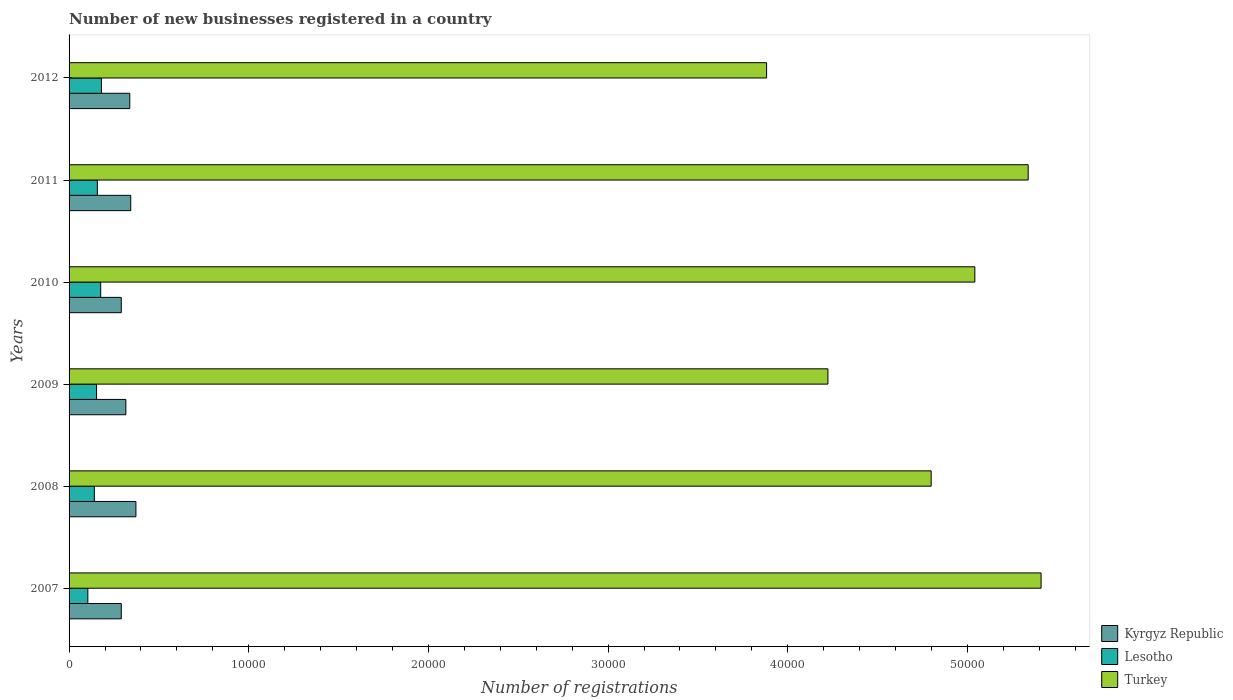How many different coloured bars are there?
Offer a terse response. 3. How many groups of bars are there?
Give a very brief answer. 6. How many bars are there on the 5th tick from the top?
Give a very brief answer. 3. What is the label of the 5th group of bars from the top?
Provide a short and direct response. 2008. In how many cases, is the number of bars for a given year not equal to the number of legend labels?
Offer a very short reply. 0. What is the number of new businesses registered in Turkey in 2012?
Give a very brief answer. 3.88e+04. Across all years, what is the maximum number of new businesses registered in Turkey?
Provide a succinct answer. 5.41e+04. Across all years, what is the minimum number of new businesses registered in Turkey?
Offer a terse response. 3.88e+04. In which year was the number of new businesses registered in Lesotho minimum?
Provide a succinct answer. 2007. What is the total number of new businesses registered in Lesotho in the graph?
Provide a short and direct response. 9118. What is the difference between the number of new businesses registered in Kyrgyz Republic in 2008 and that in 2009?
Offer a very short reply. 560. What is the difference between the number of new businesses registered in Lesotho in 2010 and the number of new businesses registered in Kyrgyz Republic in 2007?
Your answer should be very brief. -1145. What is the average number of new businesses registered in Lesotho per year?
Make the answer very short. 1519.67. In the year 2010, what is the difference between the number of new businesses registered in Lesotho and number of new businesses registered in Turkey?
Offer a very short reply. -4.87e+04. In how many years, is the number of new businesses registered in Turkey greater than 48000 ?
Provide a short and direct response. 3. What is the ratio of the number of new businesses registered in Turkey in 2010 to that in 2012?
Offer a very short reply. 1.3. What is the difference between the highest and the second highest number of new businesses registered in Lesotho?
Your response must be concise. 40. What is the difference between the highest and the lowest number of new businesses registered in Lesotho?
Keep it short and to the point. 756. In how many years, is the number of new businesses registered in Turkey greater than the average number of new businesses registered in Turkey taken over all years?
Keep it short and to the point. 4. Is the sum of the number of new businesses registered in Turkey in 2007 and 2010 greater than the maximum number of new businesses registered in Lesotho across all years?
Make the answer very short. Yes. What does the 1st bar from the top in 2010 represents?
Give a very brief answer. Turkey. What does the 2nd bar from the bottom in 2010 represents?
Give a very brief answer. Lesotho. Is it the case that in every year, the sum of the number of new businesses registered in Lesotho and number of new businesses registered in Turkey is greater than the number of new businesses registered in Kyrgyz Republic?
Provide a succinct answer. Yes. How many bars are there?
Your response must be concise. 18. What is the difference between two consecutive major ticks on the X-axis?
Make the answer very short. 10000. What is the title of the graph?
Offer a terse response. Number of new businesses registered in a country. What is the label or title of the X-axis?
Your answer should be compact. Number of registrations. What is the Number of registrations of Kyrgyz Republic in 2007?
Give a very brief answer. 2906. What is the Number of registrations in Lesotho in 2007?
Offer a terse response. 1045. What is the Number of registrations in Turkey in 2007?
Make the answer very short. 5.41e+04. What is the Number of registrations of Kyrgyz Republic in 2008?
Ensure brevity in your answer.  3721. What is the Number of registrations of Lesotho in 2008?
Ensure brevity in your answer.  1407. What is the Number of registrations of Turkey in 2008?
Keep it short and to the point. 4.80e+04. What is the Number of registrations of Kyrgyz Republic in 2009?
Your answer should be compact. 3161. What is the Number of registrations in Lesotho in 2009?
Give a very brief answer. 1531. What is the Number of registrations of Turkey in 2009?
Your response must be concise. 4.22e+04. What is the Number of registrations in Kyrgyz Republic in 2010?
Offer a terse response. 2905. What is the Number of registrations of Lesotho in 2010?
Your answer should be compact. 1761. What is the Number of registrations in Turkey in 2010?
Ensure brevity in your answer.  5.04e+04. What is the Number of registrations in Kyrgyz Republic in 2011?
Give a very brief answer. 3433. What is the Number of registrations of Lesotho in 2011?
Keep it short and to the point. 1573. What is the Number of registrations of Turkey in 2011?
Provide a short and direct response. 5.34e+04. What is the Number of registrations in Kyrgyz Republic in 2012?
Provide a short and direct response. 3379. What is the Number of registrations in Lesotho in 2012?
Ensure brevity in your answer.  1801. What is the Number of registrations in Turkey in 2012?
Give a very brief answer. 3.88e+04. Across all years, what is the maximum Number of registrations in Kyrgyz Republic?
Make the answer very short. 3721. Across all years, what is the maximum Number of registrations in Lesotho?
Provide a succinct answer. 1801. Across all years, what is the maximum Number of registrations of Turkey?
Offer a terse response. 5.41e+04. Across all years, what is the minimum Number of registrations in Kyrgyz Republic?
Give a very brief answer. 2905. Across all years, what is the minimum Number of registrations of Lesotho?
Make the answer very short. 1045. Across all years, what is the minimum Number of registrations in Turkey?
Offer a terse response. 3.88e+04. What is the total Number of registrations of Kyrgyz Republic in the graph?
Your response must be concise. 1.95e+04. What is the total Number of registrations in Lesotho in the graph?
Offer a terse response. 9118. What is the total Number of registrations of Turkey in the graph?
Ensure brevity in your answer.  2.87e+05. What is the difference between the Number of registrations of Kyrgyz Republic in 2007 and that in 2008?
Make the answer very short. -815. What is the difference between the Number of registrations of Lesotho in 2007 and that in 2008?
Offer a very short reply. -362. What is the difference between the Number of registrations in Turkey in 2007 and that in 2008?
Offer a very short reply. 6118. What is the difference between the Number of registrations in Kyrgyz Republic in 2007 and that in 2009?
Ensure brevity in your answer.  -255. What is the difference between the Number of registrations in Lesotho in 2007 and that in 2009?
Give a very brief answer. -486. What is the difference between the Number of registrations of Turkey in 2007 and that in 2009?
Your answer should be compact. 1.19e+04. What is the difference between the Number of registrations of Kyrgyz Republic in 2007 and that in 2010?
Give a very brief answer. 1. What is the difference between the Number of registrations of Lesotho in 2007 and that in 2010?
Your answer should be compact. -716. What is the difference between the Number of registrations of Turkey in 2007 and that in 2010?
Make the answer very short. 3687. What is the difference between the Number of registrations of Kyrgyz Republic in 2007 and that in 2011?
Provide a short and direct response. -527. What is the difference between the Number of registrations in Lesotho in 2007 and that in 2011?
Provide a short and direct response. -528. What is the difference between the Number of registrations of Turkey in 2007 and that in 2011?
Make the answer very short. 718. What is the difference between the Number of registrations in Kyrgyz Republic in 2007 and that in 2012?
Give a very brief answer. -473. What is the difference between the Number of registrations in Lesotho in 2007 and that in 2012?
Offer a terse response. -756. What is the difference between the Number of registrations of Turkey in 2007 and that in 2012?
Provide a short and direct response. 1.53e+04. What is the difference between the Number of registrations in Kyrgyz Republic in 2008 and that in 2009?
Ensure brevity in your answer.  560. What is the difference between the Number of registrations in Lesotho in 2008 and that in 2009?
Make the answer very short. -124. What is the difference between the Number of registrations of Turkey in 2008 and that in 2009?
Provide a succinct answer. 5746. What is the difference between the Number of registrations of Kyrgyz Republic in 2008 and that in 2010?
Provide a succinct answer. 816. What is the difference between the Number of registrations in Lesotho in 2008 and that in 2010?
Offer a very short reply. -354. What is the difference between the Number of registrations of Turkey in 2008 and that in 2010?
Your response must be concise. -2431. What is the difference between the Number of registrations in Kyrgyz Republic in 2008 and that in 2011?
Offer a very short reply. 288. What is the difference between the Number of registrations of Lesotho in 2008 and that in 2011?
Provide a short and direct response. -166. What is the difference between the Number of registrations in Turkey in 2008 and that in 2011?
Your answer should be very brief. -5400. What is the difference between the Number of registrations of Kyrgyz Republic in 2008 and that in 2012?
Provide a short and direct response. 342. What is the difference between the Number of registrations in Lesotho in 2008 and that in 2012?
Offer a terse response. -394. What is the difference between the Number of registrations in Turkey in 2008 and that in 2012?
Keep it short and to the point. 9160. What is the difference between the Number of registrations of Kyrgyz Republic in 2009 and that in 2010?
Ensure brevity in your answer.  256. What is the difference between the Number of registrations in Lesotho in 2009 and that in 2010?
Offer a very short reply. -230. What is the difference between the Number of registrations of Turkey in 2009 and that in 2010?
Make the answer very short. -8177. What is the difference between the Number of registrations in Kyrgyz Republic in 2009 and that in 2011?
Offer a very short reply. -272. What is the difference between the Number of registrations in Lesotho in 2009 and that in 2011?
Give a very brief answer. -42. What is the difference between the Number of registrations of Turkey in 2009 and that in 2011?
Ensure brevity in your answer.  -1.11e+04. What is the difference between the Number of registrations in Kyrgyz Republic in 2009 and that in 2012?
Provide a succinct answer. -218. What is the difference between the Number of registrations of Lesotho in 2009 and that in 2012?
Provide a short and direct response. -270. What is the difference between the Number of registrations of Turkey in 2009 and that in 2012?
Make the answer very short. 3414. What is the difference between the Number of registrations in Kyrgyz Republic in 2010 and that in 2011?
Ensure brevity in your answer.  -528. What is the difference between the Number of registrations of Lesotho in 2010 and that in 2011?
Make the answer very short. 188. What is the difference between the Number of registrations of Turkey in 2010 and that in 2011?
Provide a succinct answer. -2969. What is the difference between the Number of registrations in Kyrgyz Republic in 2010 and that in 2012?
Offer a terse response. -474. What is the difference between the Number of registrations in Turkey in 2010 and that in 2012?
Your answer should be very brief. 1.16e+04. What is the difference between the Number of registrations in Lesotho in 2011 and that in 2012?
Offer a terse response. -228. What is the difference between the Number of registrations in Turkey in 2011 and that in 2012?
Offer a terse response. 1.46e+04. What is the difference between the Number of registrations in Kyrgyz Republic in 2007 and the Number of registrations in Lesotho in 2008?
Ensure brevity in your answer.  1499. What is the difference between the Number of registrations of Kyrgyz Republic in 2007 and the Number of registrations of Turkey in 2008?
Offer a terse response. -4.51e+04. What is the difference between the Number of registrations in Lesotho in 2007 and the Number of registrations in Turkey in 2008?
Your response must be concise. -4.69e+04. What is the difference between the Number of registrations of Kyrgyz Republic in 2007 and the Number of registrations of Lesotho in 2009?
Make the answer very short. 1375. What is the difference between the Number of registrations of Kyrgyz Republic in 2007 and the Number of registrations of Turkey in 2009?
Keep it short and to the point. -3.93e+04. What is the difference between the Number of registrations in Lesotho in 2007 and the Number of registrations in Turkey in 2009?
Ensure brevity in your answer.  -4.12e+04. What is the difference between the Number of registrations in Kyrgyz Republic in 2007 and the Number of registrations in Lesotho in 2010?
Offer a terse response. 1145. What is the difference between the Number of registrations in Kyrgyz Republic in 2007 and the Number of registrations in Turkey in 2010?
Keep it short and to the point. -4.75e+04. What is the difference between the Number of registrations in Lesotho in 2007 and the Number of registrations in Turkey in 2010?
Give a very brief answer. -4.94e+04. What is the difference between the Number of registrations of Kyrgyz Republic in 2007 and the Number of registrations of Lesotho in 2011?
Your answer should be very brief. 1333. What is the difference between the Number of registrations in Kyrgyz Republic in 2007 and the Number of registrations in Turkey in 2011?
Give a very brief answer. -5.05e+04. What is the difference between the Number of registrations of Lesotho in 2007 and the Number of registrations of Turkey in 2011?
Keep it short and to the point. -5.23e+04. What is the difference between the Number of registrations in Kyrgyz Republic in 2007 and the Number of registrations in Lesotho in 2012?
Provide a succinct answer. 1105. What is the difference between the Number of registrations in Kyrgyz Republic in 2007 and the Number of registrations in Turkey in 2012?
Give a very brief answer. -3.59e+04. What is the difference between the Number of registrations of Lesotho in 2007 and the Number of registrations of Turkey in 2012?
Your response must be concise. -3.78e+04. What is the difference between the Number of registrations of Kyrgyz Republic in 2008 and the Number of registrations of Lesotho in 2009?
Ensure brevity in your answer.  2190. What is the difference between the Number of registrations of Kyrgyz Republic in 2008 and the Number of registrations of Turkey in 2009?
Provide a short and direct response. -3.85e+04. What is the difference between the Number of registrations in Lesotho in 2008 and the Number of registrations in Turkey in 2009?
Provide a short and direct response. -4.08e+04. What is the difference between the Number of registrations in Kyrgyz Republic in 2008 and the Number of registrations in Lesotho in 2010?
Provide a succinct answer. 1960. What is the difference between the Number of registrations of Kyrgyz Republic in 2008 and the Number of registrations of Turkey in 2010?
Provide a succinct answer. -4.67e+04. What is the difference between the Number of registrations of Lesotho in 2008 and the Number of registrations of Turkey in 2010?
Provide a succinct answer. -4.90e+04. What is the difference between the Number of registrations of Kyrgyz Republic in 2008 and the Number of registrations of Lesotho in 2011?
Your answer should be very brief. 2148. What is the difference between the Number of registrations in Kyrgyz Republic in 2008 and the Number of registrations in Turkey in 2011?
Keep it short and to the point. -4.97e+04. What is the difference between the Number of registrations in Lesotho in 2008 and the Number of registrations in Turkey in 2011?
Your answer should be compact. -5.20e+04. What is the difference between the Number of registrations in Kyrgyz Republic in 2008 and the Number of registrations in Lesotho in 2012?
Offer a terse response. 1920. What is the difference between the Number of registrations of Kyrgyz Republic in 2008 and the Number of registrations of Turkey in 2012?
Make the answer very short. -3.51e+04. What is the difference between the Number of registrations of Lesotho in 2008 and the Number of registrations of Turkey in 2012?
Your response must be concise. -3.74e+04. What is the difference between the Number of registrations of Kyrgyz Republic in 2009 and the Number of registrations of Lesotho in 2010?
Offer a terse response. 1400. What is the difference between the Number of registrations in Kyrgyz Republic in 2009 and the Number of registrations in Turkey in 2010?
Provide a short and direct response. -4.73e+04. What is the difference between the Number of registrations of Lesotho in 2009 and the Number of registrations of Turkey in 2010?
Provide a short and direct response. -4.89e+04. What is the difference between the Number of registrations in Kyrgyz Republic in 2009 and the Number of registrations in Lesotho in 2011?
Ensure brevity in your answer.  1588. What is the difference between the Number of registrations of Kyrgyz Republic in 2009 and the Number of registrations of Turkey in 2011?
Your response must be concise. -5.02e+04. What is the difference between the Number of registrations of Lesotho in 2009 and the Number of registrations of Turkey in 2011?
Keep it short and to the point. -5.19e+04. What is the difference between the Number of registrations in Kyrgyz Republic in 2009 and the Number of registrations in Lesotho in 2012?
Keep it short and to the point. 1360. What is the difference between the Number of registrations in Kyrgyz Republic in 2009 and the Number of registrations in Turkey in 2012?
Make the answer very short. -3.57e+04. What is the difference between the Number of registrations in Lesotho in 2009 and the Number of registrations in Turkey in 2012?
Make the answer very short. -3.73e+04. What is the difference between the Number of registrations in Kyrgyz Republic in 2010 and the Number of registrations in Lesotho in 2011?
Make the answer very short. 1332. What is the difference between the Number of registrations of Kyrgyz Republic in 2010 and the Number of registrations of Turkey in 2011?
Give a very brief answer. -5.05e+04. What is the difference between the Number of registrations in Lesotho in 2010 and the Number of registrations in Turkey in 2011?
Your response must be concise. -5.16e+04. What is the difference between the Number of registrations of Kyrgyz Republic in 2010 and the Number of registrations of Lesotho in 2012?
Give a very brief answer. 1104. What is the difference between the Number of registrations in Kyrgyz Republic in 2010 and the Number of registrations in Turkey in 2012?
Provide a succinct answer. -3.59e+04. What is the difference between the Number of registrations of Lesotho in 2010 and the Number of registrations of Turkey in 2012?
Keep it short and to the point. -3.71e+04. What is the difference between the Number of registrations of Kyrgyz Republic in 2011 and the Number of registrations of Lesotho in 2012?
Make the answer very short. 1632. What is the difference between the Number of registrations of Kyrgyz Republic in 2011 and the Number of registrations of Turkey in 2012?
Keep it short and to the point. -3.54e+04. What is the difference between the Number of registrations of Lesotho in 2011 and the Number of registrations of Turkey in 2012?
Make the answer very short. -3.72e+04. What is the average Number of registrations of Kyrgyz Republic per year?
Your answer should be compact. 3250.83. What is the average Number of registrations in Lesotho per year?
Ensure brevity in your answer.  1519.67. What is the average Number of registrations in Turkey per year?
Keep it short and to the point. 4.78e+04. In the year 2007, what is the difference between the Number of registrations in Kyrgyz Republic and Number of registrations in Lesotho?
Provide a short and direct response. 1861. In the year 2007, what is the difference between the Number of registrations of Kyrgyz Republic and Number of registrations of Turkey?
Give a very brief answer. -5.12e+04. In the year 2007, what is the difference between the Number of registrations of Lesotho and Number of registrations of Turkey?
Your response must be concise. -5.31e+04. In the year 2008, what is the difference between the Number of registrations of Kyrgyz Republic and Number of registrations of Lesotho?
Your answer should be compact. 2314. In the year 2008, what is the difference between the Number of registrations of Kyrgyz Republic and Number of registrations of Turkey?
Make the answer very short. -4.43e+04. In the year 2008, what is the difference between the Number of registrations of Lesotho and Number of registrations of Turkey?
Offer a very short reply. -4.66e+04. In the year 2009, what is the difference between the Number of registrations in Kyrgyz Republic and Number of registrations in Lesotho?
Your response must be concise. 1630. In the year 2009, what is the difference between the Number of registrations of Kyrgyz Republic and Number of registrations of Turkey?
Give a very brief answer. -3.91e+04. In the year 2009, what is the difference between the Number of registrations in Lesotho and Number of registrations in Turkey?
Ensure brevity in your answer.  -4.07e+04. In the year 2010, what is the difference between the Number of registrations in Kyrgyz Republic and Number of registrations in Lesotho?
Make the answer very short. 1144. In the year 2010, what is the difference between the Number of registrations in Kyrgyz Republic and Number of registrations in Turkey?
Keep it short and to the point. -4.75e+04. In the year 2010, what is the difference between the Number of registrations of Lesotho and Number of registrations of Turkey?
Make the answer very short. -4.87e+04. In the year 2011, what is the difference between the Number of registrations of Kyrgyz Republic and Number of registrations of Lesotho?
Provide a succinct answer. 1860. In the year 2011, what is the difference between the Number of registrations in Kyrgyz Republic and Number of registrations in Turkey?
Your response must be concise. -5.00e+04. In the year 2011, what is the difference between the Number of registrations of Lesotho and Number of registrations of Turkey?
Keep it short and to the point. -5.18e+04. In the year 2012, what is the difference between the Number of registrations in Kyrgyz Republic and Number of registrations in Lesotho?
Your response must be concise. 1578. In the year 2012, what is the difference between the Number of registrations in Kyrgyz Republic and Number of registrations in Turkey?
Offer a terse response. -3.54e+04. In the year 2012, what is the difference between the Number of registrations of Lesotho and Number of registrations of Turkey?
Ensure brevity in your answer.  -3.70e+04. What is the ratio of the Number of registrations in Kyrgyz Republic in 2007 to that in 2008?
Your answer should be compact. 0.78. What is the ratio of the Number of registrations of Lesotho in 2007 to that in 2008?
Give a very brief answer. 0.74. What is the ratio of the Number of registrations in Turkey in 2007 to that in 2008?
Provide a short and direct response. 1.13. What is the ratio of the Number of registrations of Kyrgyz Republic in 2007 to that in 2009?
Your answer should be compact. 0.92. What is the ratio of the Number of registrations in Lesotho in 2007 to that in 2009?
Your response must be concise. 0.68. What is the ratio of the Number of registrations in Turkey in 2007 to that in 2009?
Ensure brevity in your answer.  1.28. What is the ratio of the Number of registrations of Lesotho in 2007 to that in 2010?
Give a very brief answer. 0.59. What is the ratio of the Number of registrations in Turkey in 2007 to that in 2010?
Keep it short and to the point. 1.07. What is the ratio of the Number of registrations of Kyrgyz Republic in 2007 to that in 2011?
Ensure brevity in your answer.  0.85. What is the ratio of the Number of registrations of Lesotho in 2007 to that in 2011?
Your response must be concise. 0.66. What is the ratio of the Number of registrations in Turkey in 2007 to that in 2011?
Make the answer very short. 1.01. What is the ratio of the Number of registrations in Kyrgyz Republic in 2007 to that in 2012?
Make the answer very short. 0.86. What is the ratio of the Number of registrations of Lesotho in 2007 to that in 2012?
Ensure brevity in your answer.  0.58. What is the ratio of the Number of registrations in Turkey in 2007 to that in 2012?
Keep it short and to the point. 1.39. What is the ratio of the Number of registrations of Kyrgyz Republic in 2008 to that in 2009?
Your response must be concise. 1.18. What is the ratio of the Number of registrations in Lesotho in 2008 to that in 2009?
Your answer should be very brief. 0.92. What is the ratio of the Number of registrations in Turkey in 2008 to that in 2009?
Make the answer very short. 1.14. What is the ratio of the Number of registrations of Kyrgyz Republic in 2008 to that in 2010?
Your answer should be very brief. 1.28. What is the ratio of the Number of registrations in Lesotho in 2008 to that in 2010?
Offer a terse response. 0.8. What is the ratio of the Number of registrations of Turkey in 2008 to that in 2010?
Keep it short and to the point. 0.95. What is the ratio of the Number of registrations of Kyrgyz Republic in 2008 to that in 2011?
Offer a terse response. 1.08. What is the ratio of the Number of registrations of Lesotho in 2008 to that in 2011?
Keep it short and to the point. 0.89. What is the ratio of the Number of registrations in Turkey in 2008 to that in 2011?
Provide a short and direct response. 0.9. What is the ratio of the Number of registrations in Kyrgyz Republic in 2008 to that in 2012?
Provide a short and direct response. 1.1. What is the ratio of the Number of registrations of Lesotho in 2008 to that in 2012?
Ensure brevity in your answer.  0.78. What is the ratio of the Number of registrations of Turkey in 2008 to that in 2012?
Your answer should be very brief. 1.24. What is the ratio of the Number of registrations in Kyrgyz Republic in 2009 to that in 2010?
Provide a short and direct response. 1.09. What is the ratio of the Number of registrations in Lesotho in 2009 to that in 2010?
Your answer should be compact. 0.87. What is the ratio of the Number of registrations in Turkey in 2009 to that in 2010?
Offer a terse response. 0.84. What is the ratio of the Number of registrations in Kyrgyz Republic in 2009 to that in 2011?
Your answer should be very brief. 0.92. What is the ratio of the Number of registrations in Lesotho in 2009 to that in 2011?
Ensure brevity in your answer.  0.97. What is the ratio of the Number of registrations in Turkey in 2009 to that in 2011?
Ensure brevity in your answer.  0.79. What is the ratio of the Number of registrations of Kyrgyz Republic in 2009 to that in 2012?
Provide a succinct answer. 0.94. What is the ratio of the Number of registrations of Lesotho in 2009 to that in 2012?
Provide a succinct answer. 0.85. What is the ratio of the Number of registrations of Turkey in 2009 to that in 2012?
Your answer should be compact. 1.09. What is the ratio of the Number of registrations in Kyrgyz Republic in 2010 to that in 2011?
Your response must be concise. 0.85. What is the ratio of the Number of registrations in Lesotho in 2010 to that in 2011?
Ensure brevity in your answer.  1.12. What is the ratio of the Number of registrations in Kyrgyz Republic in 2010 to that in 2012?
Your response must be concise. 0.86. What is the ratio of the Number of registrations in Lesotho in 2010 to that in 2012?
Provide a short and direct response. 0.98. What is the ratio of the Number of registrations of Turkey in 2010 to that in 2012?
Keep it short and to the point. 1.3. What is the ratio of the Number of registrations in Lesotho in 2011 to that in 2012?
Keep it short and to the point. 0.87. What is the ratio of the Number of registrations in Turkey in 2011 to that in 2012?
Your response must be concise. 1.38. What is the difference between the highest and the second highest Number of registrations in Kyrgyz Republic?
Provide a succinct answer. 288. What is the difference between the highest and the second highest Number of registrations in Lesotho?
Offer a terse response. 40. What is the difference between the highest and the second highest Number of registrations in Turkey?
Give a very brief answer. 718. What is the difference between the highest and the lowest Number of registrations of Kyrgyz Republic?
Your answer should be very brief. 816. What is the difference between the highest and the lowest Number of registrations in Lesotho?
Your response must be concise. 756. What is the difference between the highest and the lowest Number of registrations of Turkey?
Provide a short and direct response. 1.53e+04. 